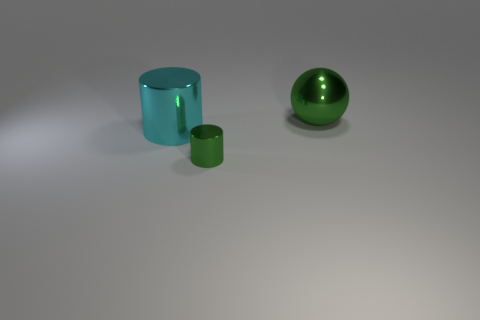Subtract all cyan cylinders. How many cylinders are left? 1 Add 1 cyan metal objects. How many objects exist? 4 Subtract all spheres. How many objects are left? 2 Subtract 1 cylinders. How many cylinders are left? 1 Subtract 0 brown blocks. How many objects are left? 3 Subtract all yellow spheres. Subtract all yellow cylinders. How many spheres are left? 1 Subtract all cyan spheres. How many cyan cylinders are left? 1 Subtract all green objects. Subtract all small purple cylinders. How many objects are left? 1 Add 3 green things. How many green things are left? 5 Add 2 tiny yellow matte objects. How many tiny yellow matte objects exist? 2 